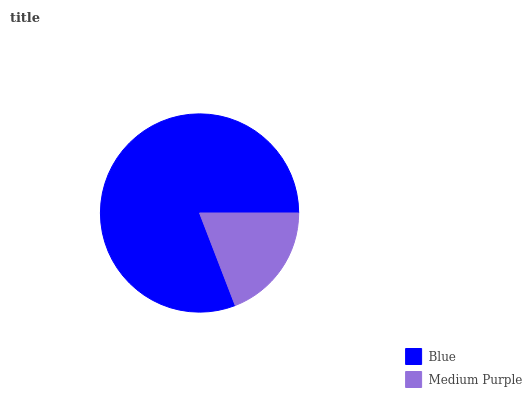Is Medium Purple the minimum?
Answer yes or no. Yes. Is Blue the maximum?
Answer yes or no. Yes. Is Medium Purple the maximum?
Answer yes or no. No. Is Blue greater than Medium Purple?
Answer yes or no. Yes. Is Medium Purple less than Blue?
Answer yes or no. Yes. Is Medium Purple greater than Blue?
Answer yes or no. No. Is Blue less than Medium Purple?
Answer yes or no. No. Is Blue the high median?
Answer yes or no. Yes. Is Medium Purple the low median?
Answer yes or no. Yes. Is Medium Purple the high median?
Answer yes or no. No. Is Blue the low median?
Answer yes or no. No. 